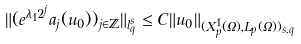Convert formula to latex. <formula><loc_0><loc_0><loc_500><loc_500>\| ( e ^ { \lambda _ { 1 } 2 ^ { j } } a _ { j } ( u _ { 0 } ) ) _ { j \in \mathbb { Z } } \| _ { l ^ { s } _ { q } } \leq C \| u _ { 0 } \| _ { ( X ^ { 1 } _ { p } ( \Omega ) , L _ { p } ( \Omega ) ) _ { s , q } }</formula> 